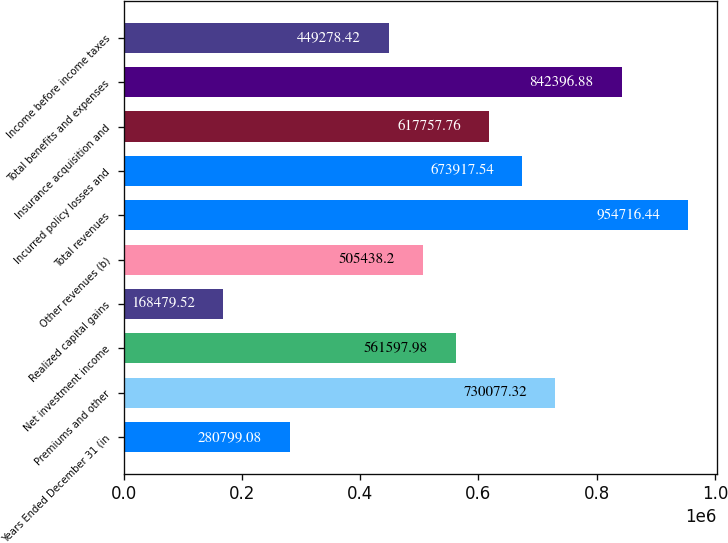<chart> <loc_0><loc_0><loc_500><loc_500><bar_chart><fcel>Years Ended December 31 (in<fcel>Premiums and other<fcel>Net investment income<fcel>Realized capital gains<fcel>Other revenues (b)<fcel>Total revenues<fcel>Incurred policy losses and<fcel>Insurance acquisition and<fcel>Total benefits and expenses<fcel>Income before income taxes<nl><fcel>280799<fcel>730077<fcel>561598<fcel>168480<fcel>505438<fcel>954716<fcel>673918<fcel>617758<fcel>842397<fcel>449278<nl></chart> 